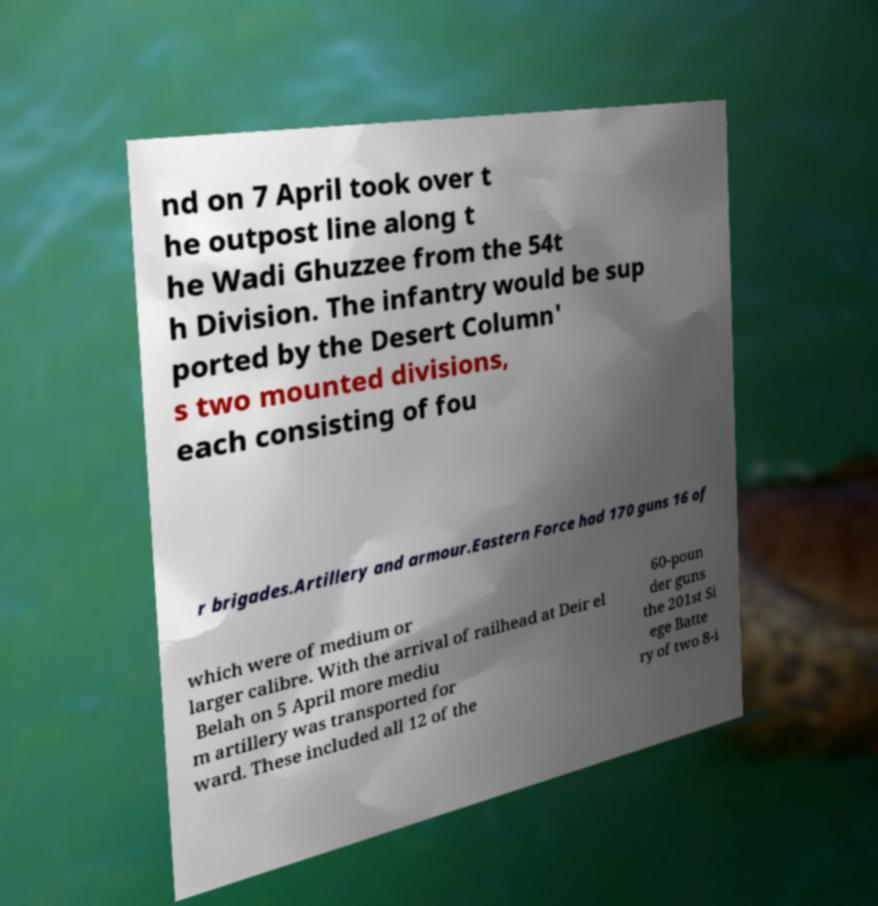I need the written content from this picture converted into text. Can you do that? nd on 7 April took over t he outpost line along t he Wadi Ghuzzee from the 54t h Division. The infantry would be sup ported by the Desert Column' s two mounted divisions, each consisting of fou r brigades.Artillery and armour.Eastern Force had 170 guns 16 of which were of medium or larger calibre. With the arrival of railhead at Deir el Belah on 5 April more mediu m artillery was transported for ward. These included all 12 of the 60-poun der guns the 201st Si ege Batte ry of two 8-i 